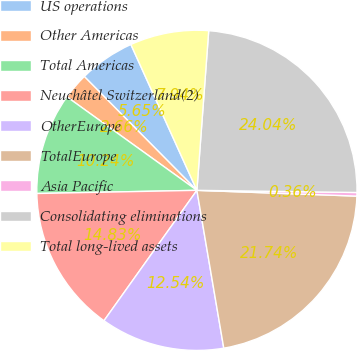<chart> <loc_0><loc_0><loc_500><loc_500><pie_chart><fcel>US operations<fcel>Other Americas<fcel>Total Americas<fcel>Neuchâtel Switzerland(2)<fcel>OtherEurope<fcel>TotalEurope<fcel>Asia Pacific<fcel>Consolidating eliminations<fcel>Total long-lived assets<nl><fcel>5.65%<fcel>2.66%<fcel>10.24%<fcel>14.83%<fcel>12.54%<fcel>21.74%<fcel>0.36%<fcel>24.04%<fcel>7.94%<nl></chart> 